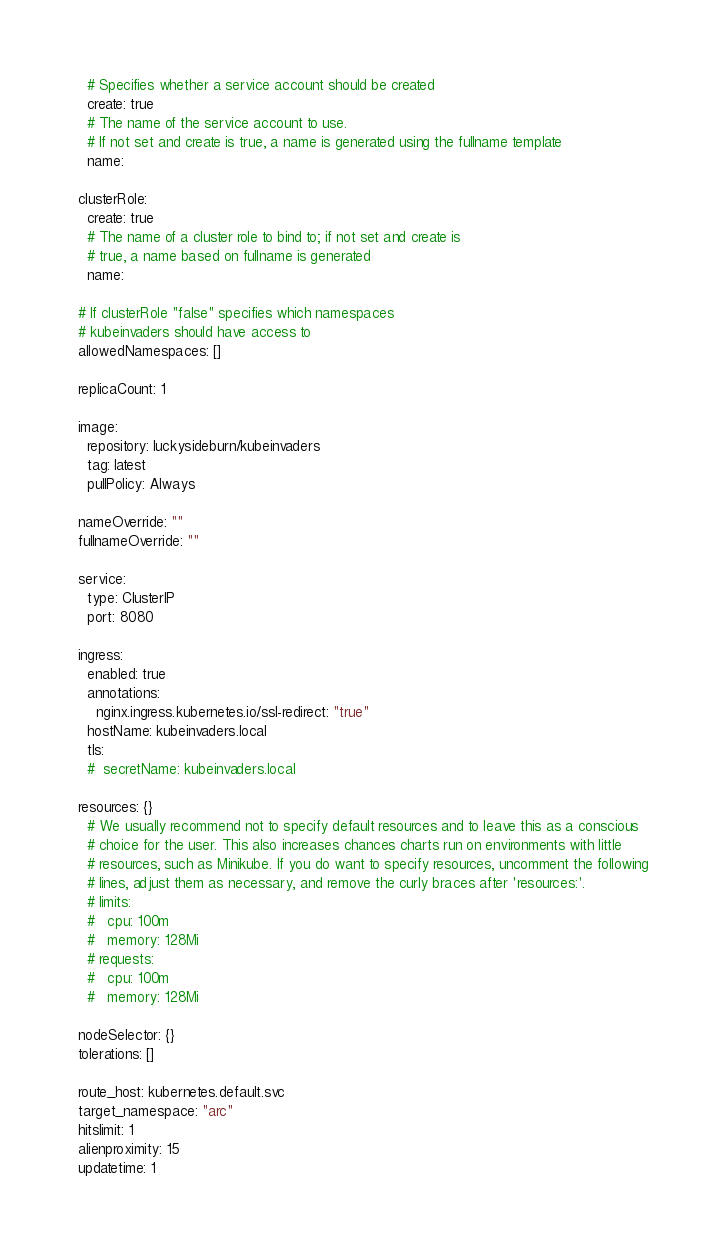Convert code to text. <code><loc_0><loc_0><loc_500><loc_500><_YAML_>  # Specifies whether a service account should be created
  create: true
  # The name of the service account to use.
  # If not set and create is true, a name is generated using the fullname template
  name:

clusterRole:
  create: true
  # The name of a cluster role to bind to; if not set and create is
  # true, a name based on fullname is generated
  name:

# If clusterRole "false" specifies which namespaces
# kubeinvaders should have access to
allowedNamespaces: []

replicaCount: 1

image:
  repository: luckysideburn/kubeinvaders
  tag: latest
  pullPolicy: Always

nameOverride: ""
fullnameOverride: ""

service:
  type: ClusterIP
  port: 8080

ingress:
  enabled: true
  annotations:
    nginx.ingress.kubernetes.io/ssl-redirect: "true"
  hostName: kubeinvaders.local
  tls:
  #  secretName: kubeinvaders.local

resources: {}
  # We usually recommend not to specify default resources and to leave this as a conscious
  # choice for the user. This also increases chances charts run on environments with little
  # resources, such as Minikube. If you do want to specify resources, uncomment the following
  # lines, adjust them as necessary, and remove the curly braces after 'resources:'.
  # limits:
  #   cpu: 100m
  #   memory: 128Mi
  # requests:
  #   cpu: 100m
  #   memory: 128Mi

nodeSelector: {}
tolerations: []

route_host: kubernetes.default.svc
target_namespace: "arc"
hitslimit: 1
alienproximity: 15
updatetime: 1
</code> 